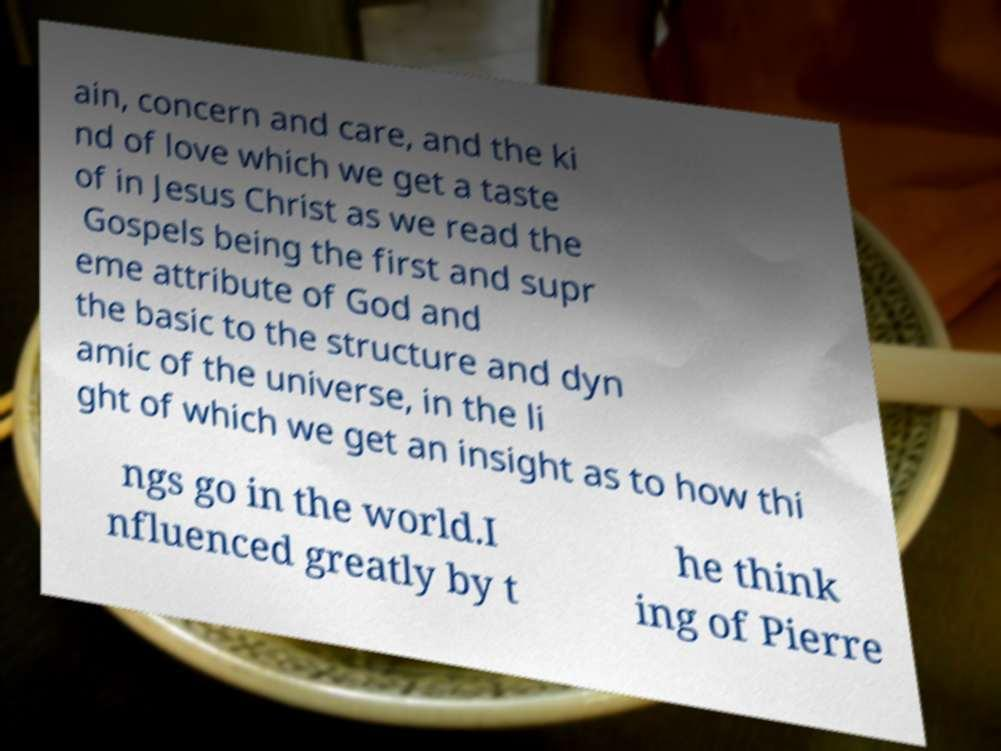Could you extract and type out the text from this image? ain, concern and care, and the ki nd of love which we get a taste of in Jesus Christ as we read the Gospels being the first and supr eme attribute of God and the basic to the structure and dyn amic of the universe, in the li ght of which we get an insight as to how thi ngs go in the world.I nfluenced greatly by t he think ing of Pierre 